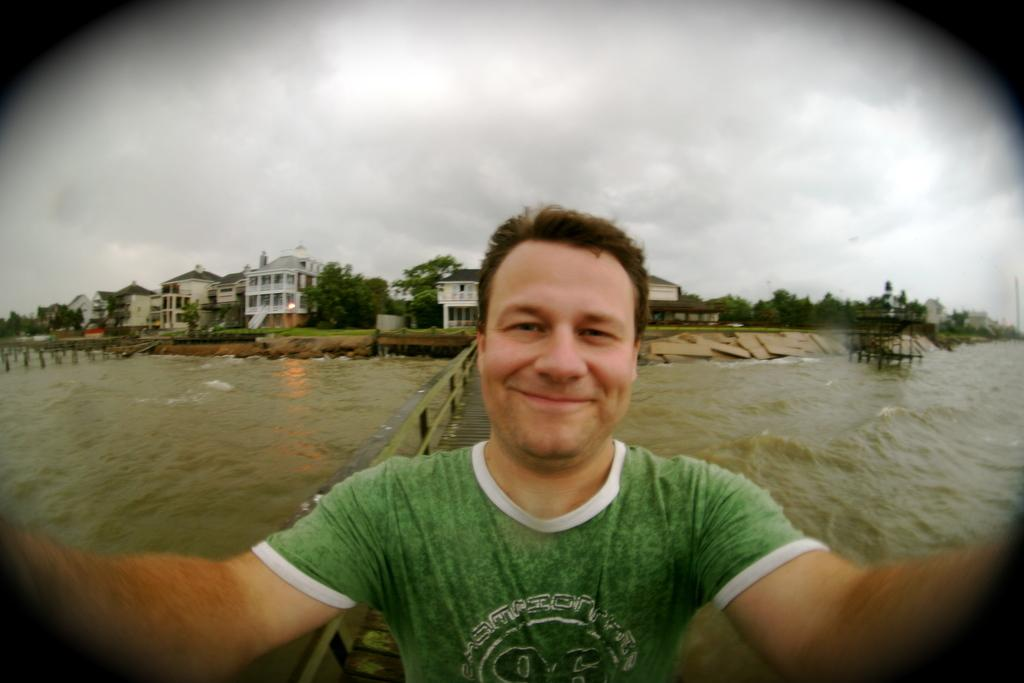Who or what is present in the image? There is a person in the image. What is the person doing or expressing? The person is smiling. What can be seen in the background of the image? There is a bridgewater, buildings, a cloudy sky, and trees in the background of the image. How many chairs are visible in the image? There are no chairs present in the image. 